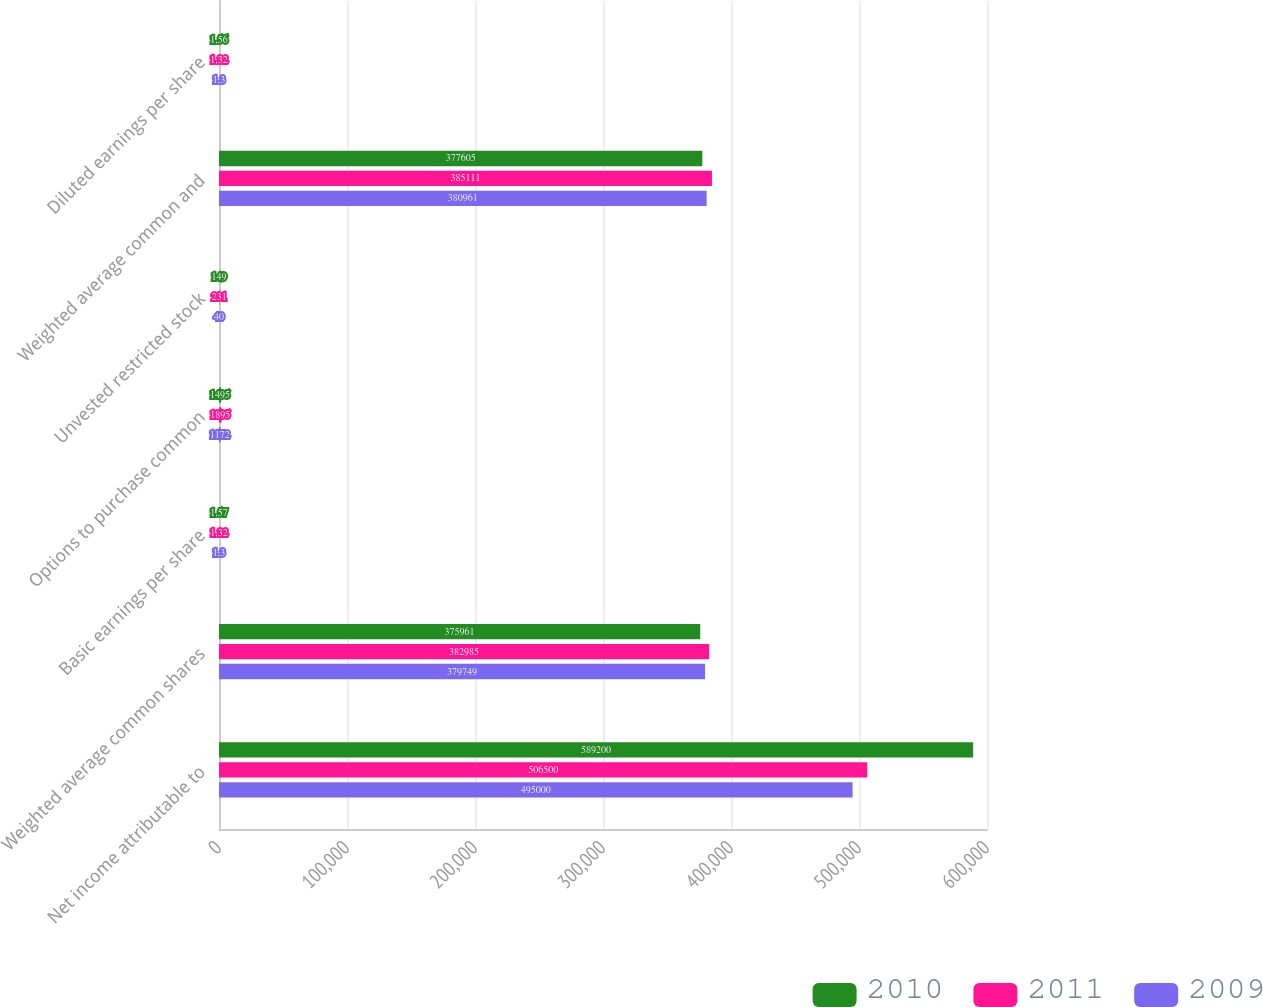Convert chart. <chart><loc_0><loc_0><loc_500><loc_500><stacked_bar_chart><ecel><fcel>Net income attributable to<fcel>Weighted average common shares<fcel>Basic earnings per share<fcel>Options to purchase common<fcel>Unvested restricted stock<fcel>Weighted average common and<fcel>Diluted earnings per share<nl><fcel>2010<fcel>589200<fcel>375961<fcel>1.57<fcel>1495<fcel>149<fcel>377605<fcel>1.56<nl><fcel>2011<fcel>506500<fcel>382985<fcel>1.32<fcel>1895<fcel>231<fcel>385111<fcel>1.32<nl><fcel>2009<fcel>495000<fcel>379749<fcel>1.3<fcel>1172<fcel>40<fcel>380961<fcel>1.3<nl></chart> 